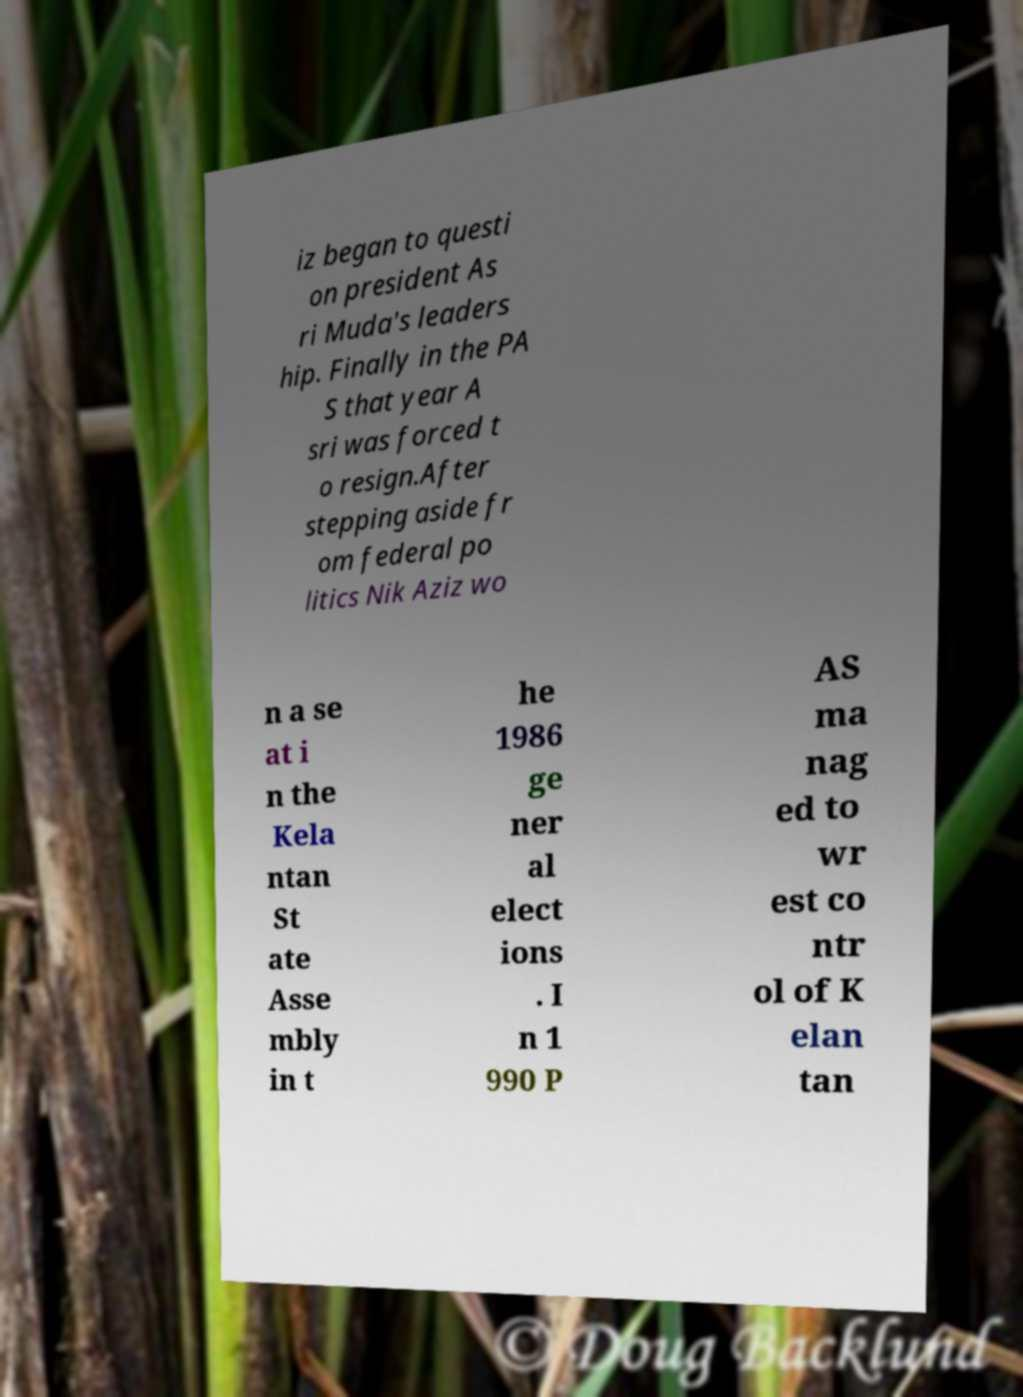Can you read and provide the text displayed in the image?This photo seems to have some interesting text. Can you extract and type it out for me? iz began to questi on president As ri Muda's leaders hip. Finally in the PA S that year A sri was forced t o resign.After stepping aside fr om federal po litics Nik Aziz wo n a se at i n the Kela ntan St ate Asse mbly in t he 1986 ge ner al elect ions . I n 1 990 P AS ma nag ed to wr est co ntr ol of K elan tan 